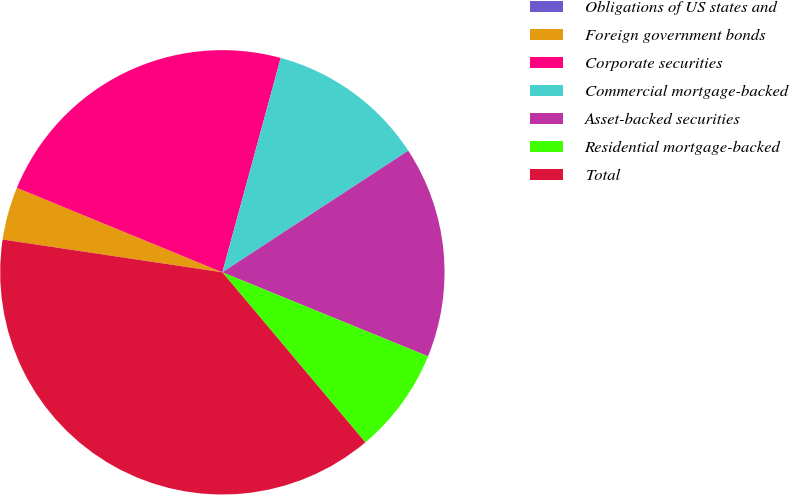Convert chart. <chart><loc_0><loc_0><loc_500><loc_500><pie_chart><fcel>Obligations of US states and<fcel>Foreign government bonds<fcel>Corporate securities<fcel>Commercial mortgage-backed<fcel>Asset-backed securities<fcel>Residential mortgage-backed<fcel>Total<nl><fcel>0.0%<fcel>3.85%<fcel>23.02%<fcel>11.55%<fcel>15.39%<fcel>7.7%<fcel>38.48%<nl></chart> 